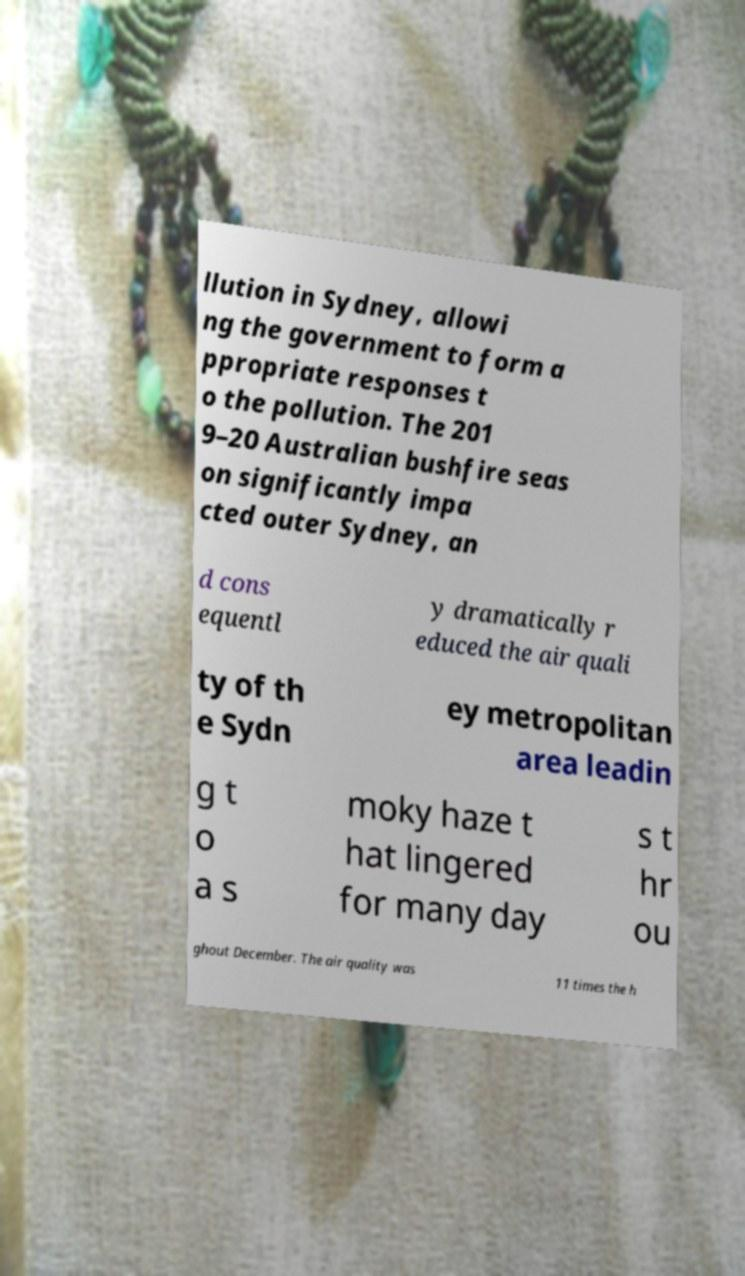Please identify and transcribe the text found in this image. llution in Sydney, allowi ng the government to form a ppropriate responses t o the pollution. The 201 9–20 Australian bushfire seas on significantly impa cted outer Sydney, an d cons equentl y dramatically r educed the air quali ty of th e Sydn ey metropolitan area leadin g t o a s moky haze t hat lingered for many day s t hr ou ghout December. The air quality was 11 times the h 